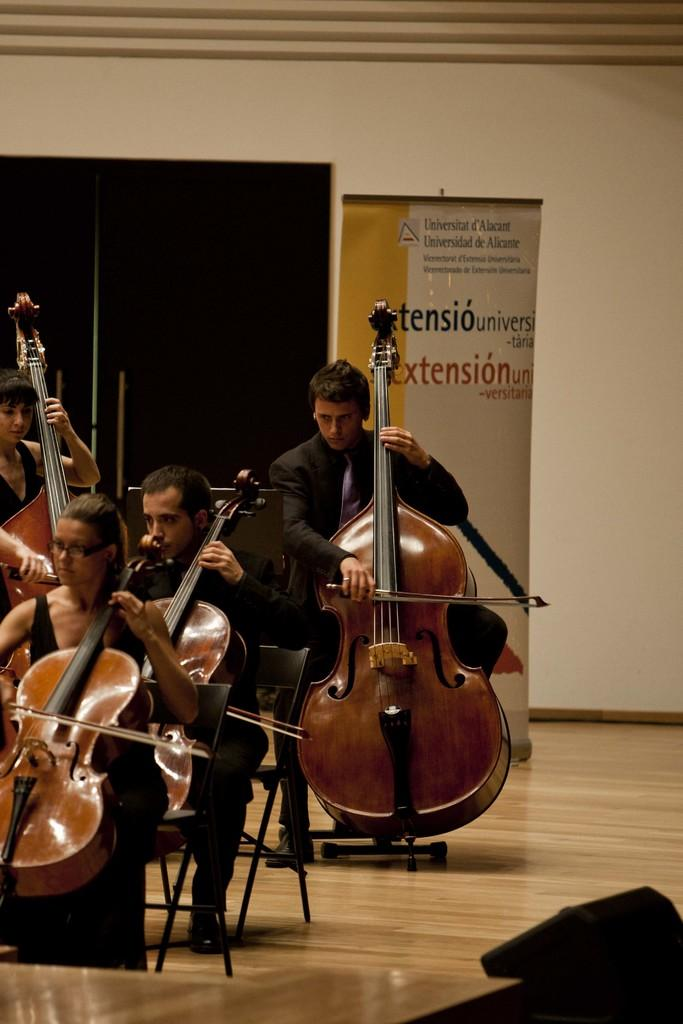What are the four people in the image doing? The four people are holding violins and playing them. How are the two persons in the front positioned? They are sitting on chairs in the front. What can be seen in the background of the image? There is a banner, a wall, and a door in the background. How many thumbs can be seen playing the violins in the image? There is no specific mention of thumbs in the image, as the focus is on the people playing the violins. What idea is being expressed on the banner in the background? The image does not provide any information about the content of the banner, so we cannot determine what idea it might be expressing. 